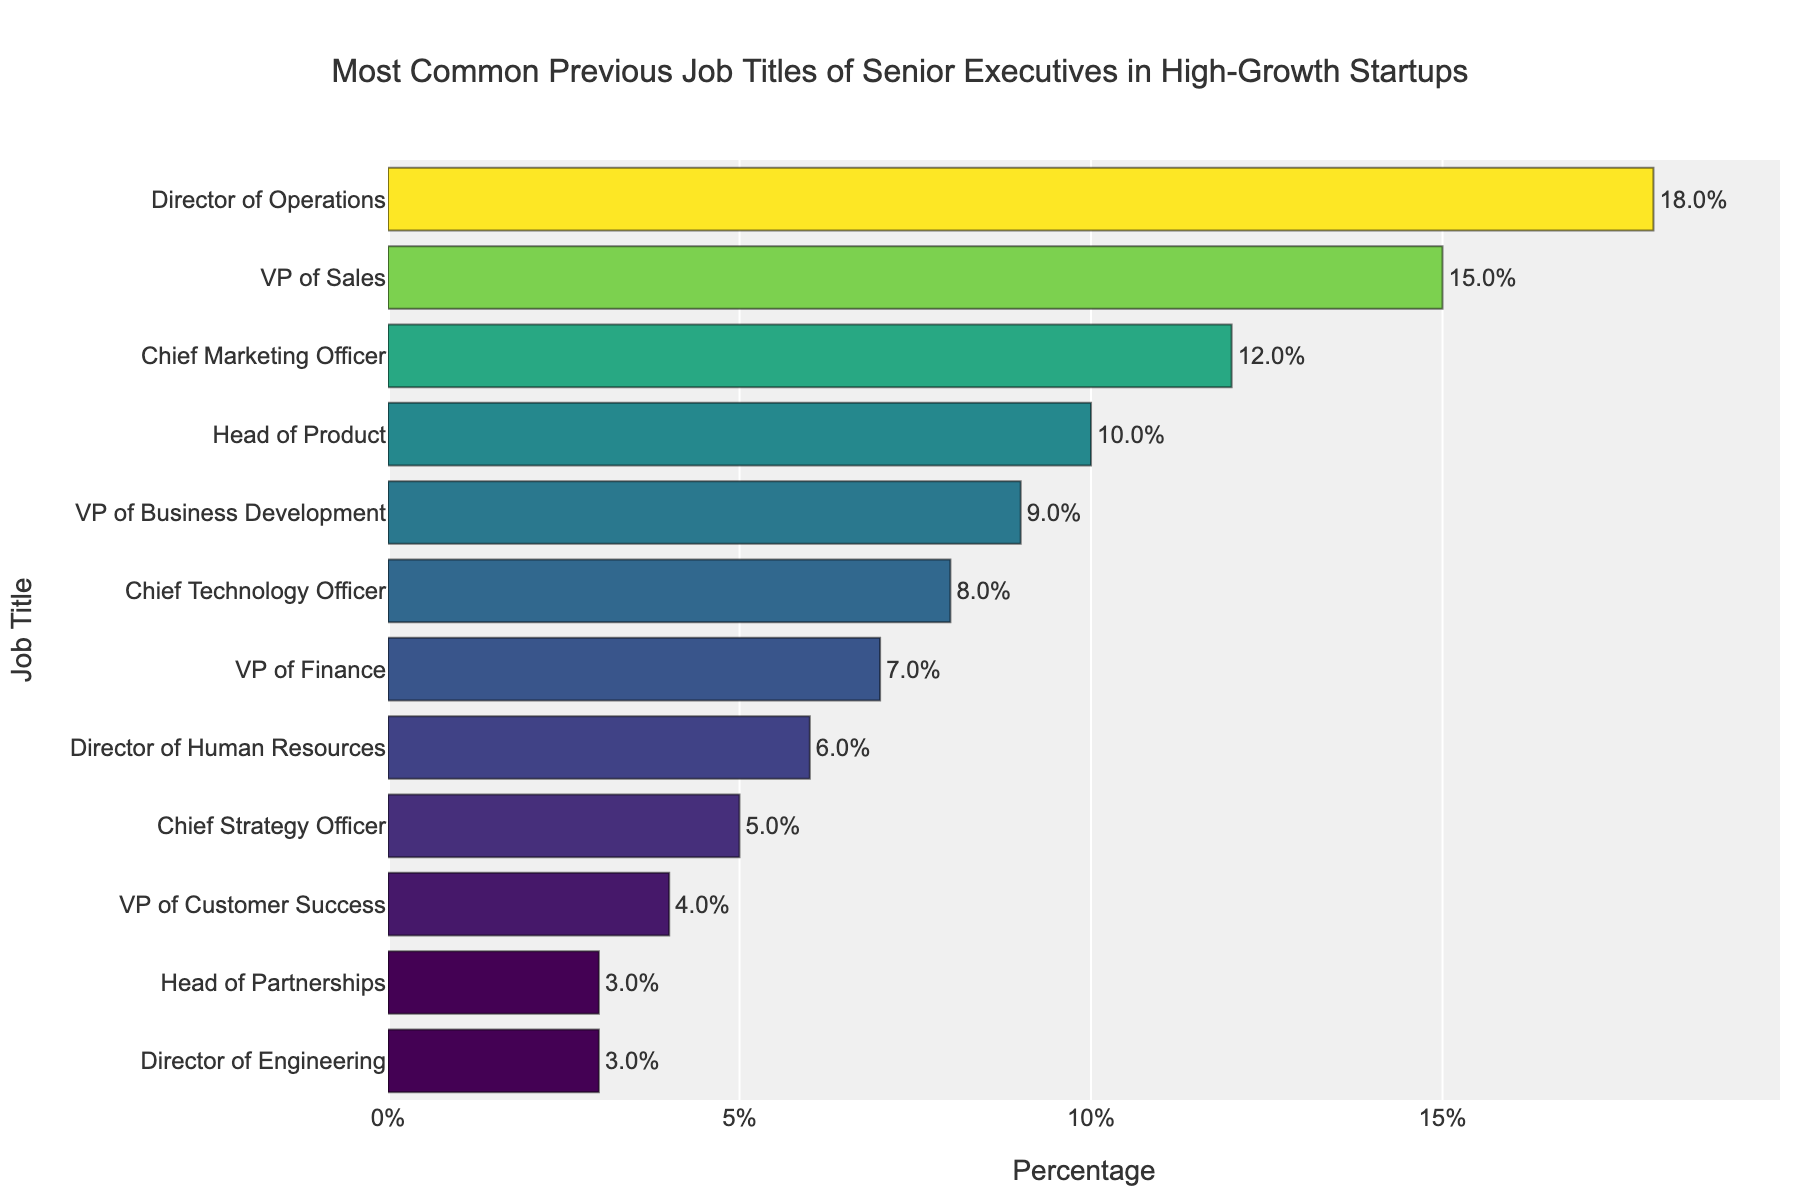Which job title has the highest percentage? The figure shows the bar representing the 'Director of Operations' category extending the furthest, indicating it has the highest percentage.
Answer: Director of Operations What's the sum of the percentages for 'Director of Operations' and 'VP of Sales'? The 'Director of Operations' has 18% and the 'VP of Sales' has 15%. Adding these together gives 18% + 15% = 33%.
Answer: 33% Is the percentage for 'Chief Marketing Officer' greater than 'Chief Technology Officer'? The figure shows 'Chief Marketing Officer' with 12% and 'Chief Technology Officer' with 8%, so 12% is greater than 8%.
Answer: Yes Which job titles have a percentage higher than 10%? By examining the bars visually, the 'Director of Operations' (18%), 'VP of Sales' (15%), and 'Chief Marketing Officer' (12%) all have bars extending past the 10% mark.
Answer: Director of Operations, VP of Sales, Chief Marketing Officer What’s the difference in percentage between 'Director of Human Resources' and 'Chief Strategy Officer'? 'Director of Human Resources' has 6% and 'Chief Strategy Officer' has 5%. The difference is 6% - 5% = 1%.
Answer: 1% Which job title has the smallest percentage and what is its value? The figure shows the 'Director of Engineering' and 'Head of Partnerships' have the shortest bars, both at 3%.
Answer: Director of Engineering, Head of Partnerships; 3% How many job titles have percentages less than 5%? By observing the figure, 'VP of Customer Success' (4%), 'Head of Partnerships' (3%), and 'Director of Engineering' (3%) each have percentages less than 5%. Count these to get three job titles.
Answer: 3 If you add the percentages of 'Chief Technology Officer' and 'VP of Finance', what do you get? 'Chief Technology Officer' has 8% and 'VP of Finance' has 7%. Adding these together gives 8% + 7% = 15%.
Answer: 15% Which job title has a percentage closest to the median percentage? First, list the percentages in order: 3, 3, 4, 5, 6, 7, 8, 9, 10, 12, 15, 18. The median is the average of the 6th and 7th values (7 and 8). So, (7+8)/2 = 7.5%, and the closest job title percentage is 'VP of Finance' at 7%.
Answer: VP of Finance 